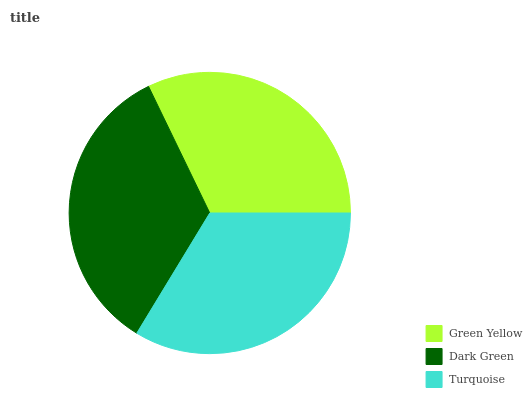Is Green Yellow the minimum?
Answer yes or no. Yes. Is Dark Green the maximum?
Answer yes or no. Yes. Is Turquoise the minimum?
Answer yes or no. No. Is Turquoise the maximum?
Answer yes or no. No. Is Dark Green greater than Turquoise?
Answer yes or no. Yes. Is Turquoise less than Dark Green?
Answer yes or no. Yes. Is Turquoise greater than Dark Green?
Answer yes or no. No. Is Dark Green less than Turquoise?
Answer yes or no. No. Is Turquoise the high median?
Answer yes or no. Yes. Is Turquoise the low median?
Answer yes or no. Yes. Is Dark Green the high median?
Answer yes or no. No. Is Green Yellow the low median?
Answer yes or no. No. 